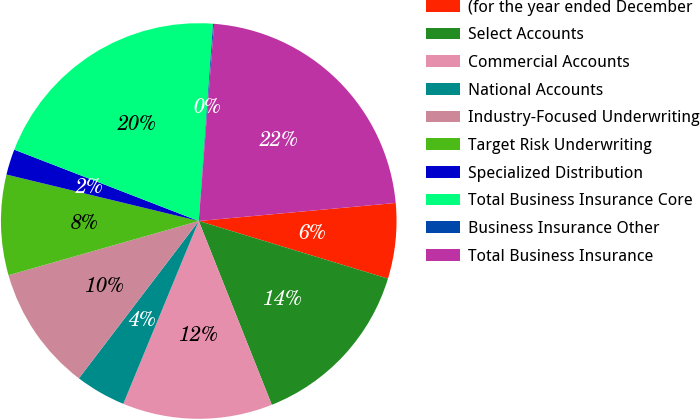Convert chart. <chart><loc_0><loc_0><loc_500><loc_500><pie_chart><fcel>(for the year ended December<fcel>Select Accounts<fcel>Commercial Accounts<fcel>National Accounts<fcel>Industry-Focused Underwriting<fcel>Target Risk Underwriting<fcel>Specialized Distribution<fcel>Total Business Insurance Core<fcel>Business Insurance Other<fcel>Total Business Insurance<nl><fcel>6.16%<fcel>14.27%<fcel>12.25%<fcel>4.13%<fcel>10.22%<fcel>8.19%<fcel>2.1%<fcel>20.28%<fcel>0.08%<fcel>22.31%<nl></chart> 